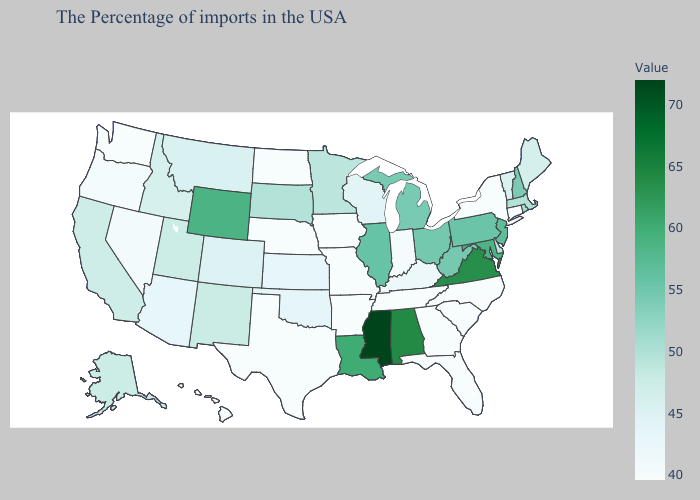Does Rhode Island have the highest value in the USA?
Write a very short answer. No. Which states have the highest value in the USA?
Be succinct. Mississippi. Does Georgia have the lowest value in the USA?
Quick response, please. Yes. Among the states that border Pennsylvania , which have the lowest value?
Give a very brief answer. New York. 